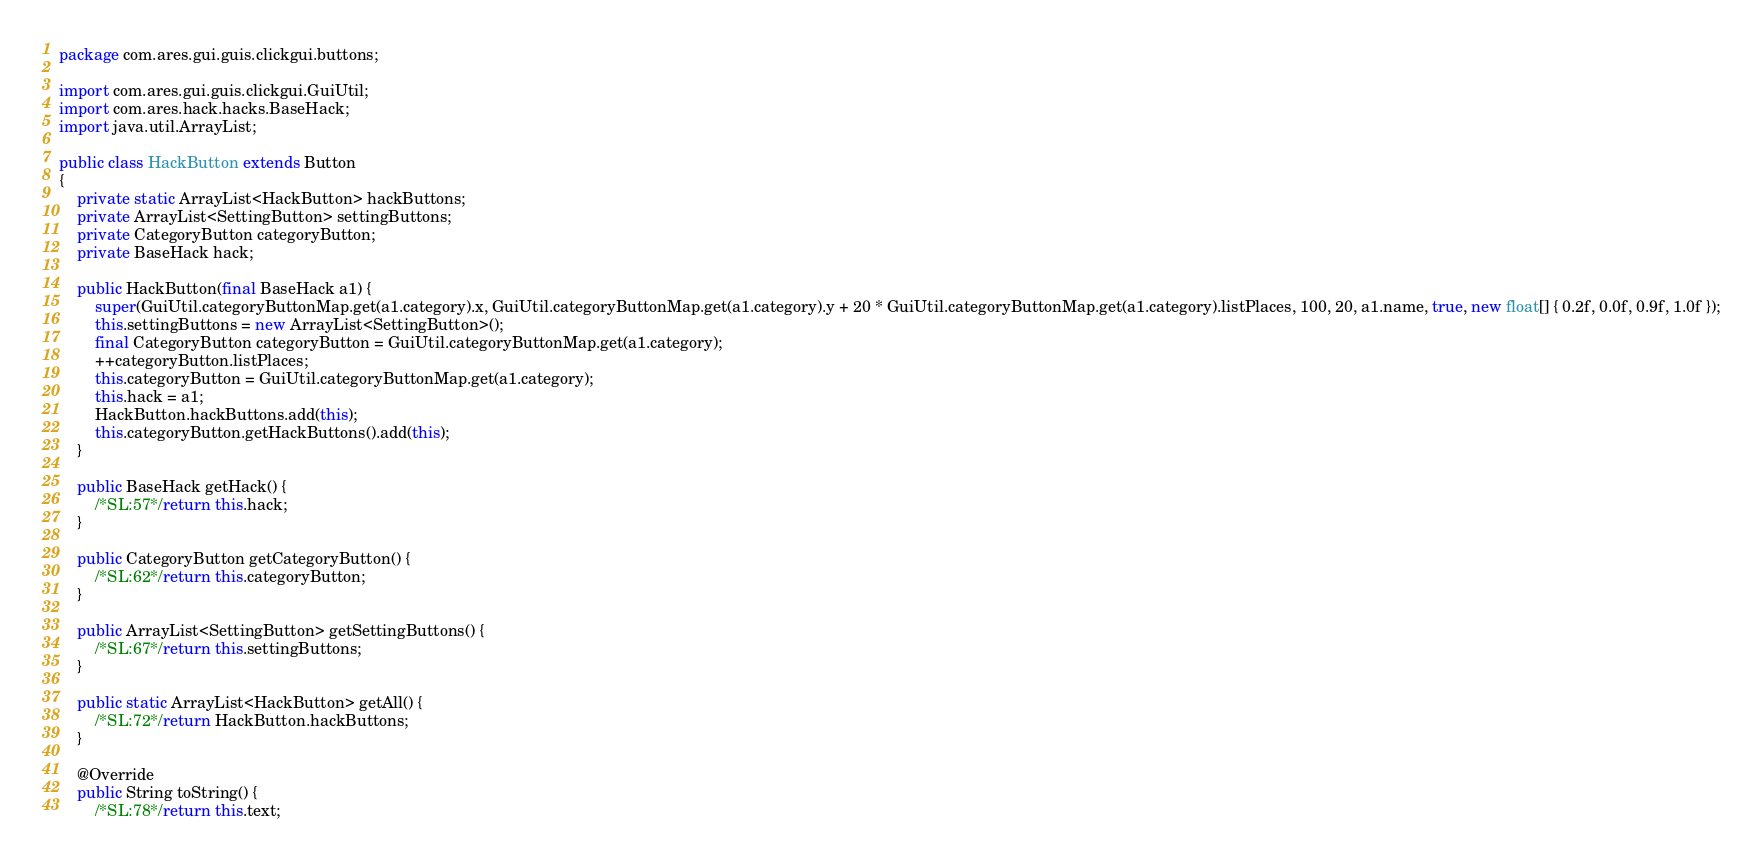<code> <loc_0><loc_0><loc_500><loc_500><_Java_>package com.ares.gui.guis.clickgui.buttons;

import com.ares.gui.guis.clickgui.GuiUtil;
import com.ares.hack.hacks.BaseHack;
import java.util.ArrayList;

public class HackButton extends Button
{
    private static ArrayList<HackButton> hackButtons;
    private ArrayList<SettingButton> settingButtons;
    private CategoryButton categoryButton;
    private BaseHack hack;
    
    public HackButton(final BaseHack a1) {
        super(GuiUtil.categoryButtonMap.get(a1.category).x, GuiUtil.categoryButtonMap.get(a1.category).y + 20 * GuiUtil.categoryButtonMap.get(a1.category).listPlaces, 100, 20, a1.name, true, new float[] { 0.2f, 0.0f, 0.9f, 1.0f });
        this.settingButtons = new ArrayList<SettingButton>();
        final CategoryButton categoryButton = GuiUtil.categoryButtonMap.get(a1.category);
        ++categoryButton.listPlaces;
        this.categoryButton = GuiUtil.categoryButtonMap.get(a1.category);
        this.hack = a1;
        HackButton.hackButtons.add(this);
        this.categoryButton.getHackButtons().add(this);
    }
    
    public BaseHack getHack() {
        /*SL:57*/return this.hack;
    }
    
    public CategoryButton getCategoryButton() {
        /*SL:62*/return this.categoryButton;
    }
    
    public ArrayList<SettingButton> getSettingButtons() {
        /*SL:67*/return this.settingButtons;
    }
    
    public static ArrayList<HackButton> getAll() {
        /*SL:72*/return HackButton.hackButtons;
    }
    
    @Override
    public String toString() {
        /*SL:78*/return this.text;</code> 